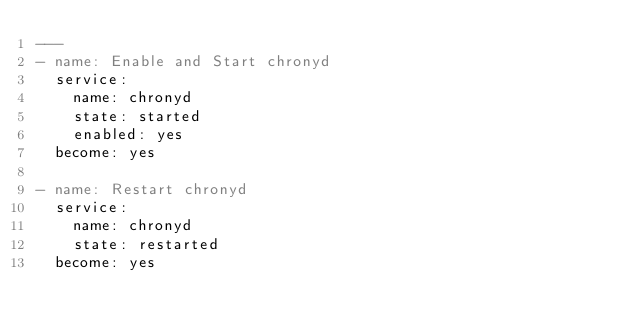Convert code to text. <code><loc_0><loc_0><loc_500><loc_500><_YAML_>---
- name: Enable and Start chronyd
  service:
    name: chronyd
    state: started
    enabled: yes
  become: yes

- name: Restart chronyd
  service:
    name: chronyd
    state: restarted
  become: yes
</code> 